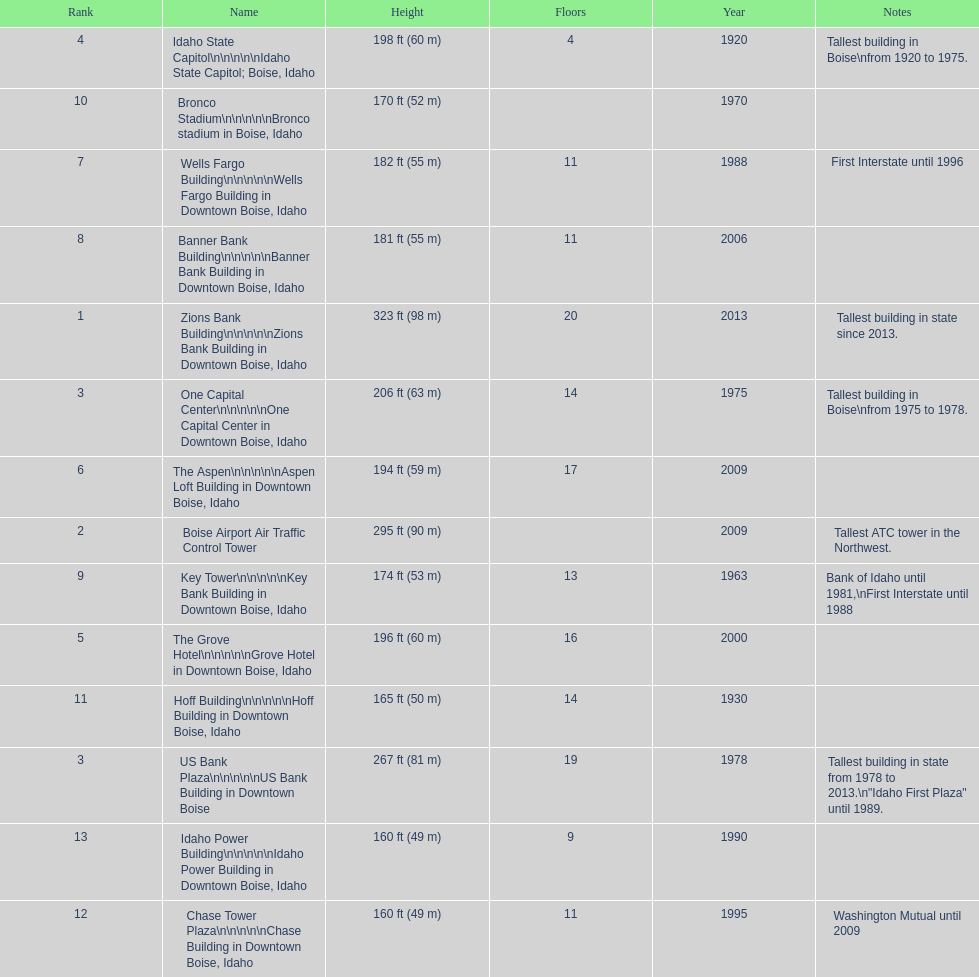What is the name of the building listed after idaho state capitol? The Grove Hotel. 